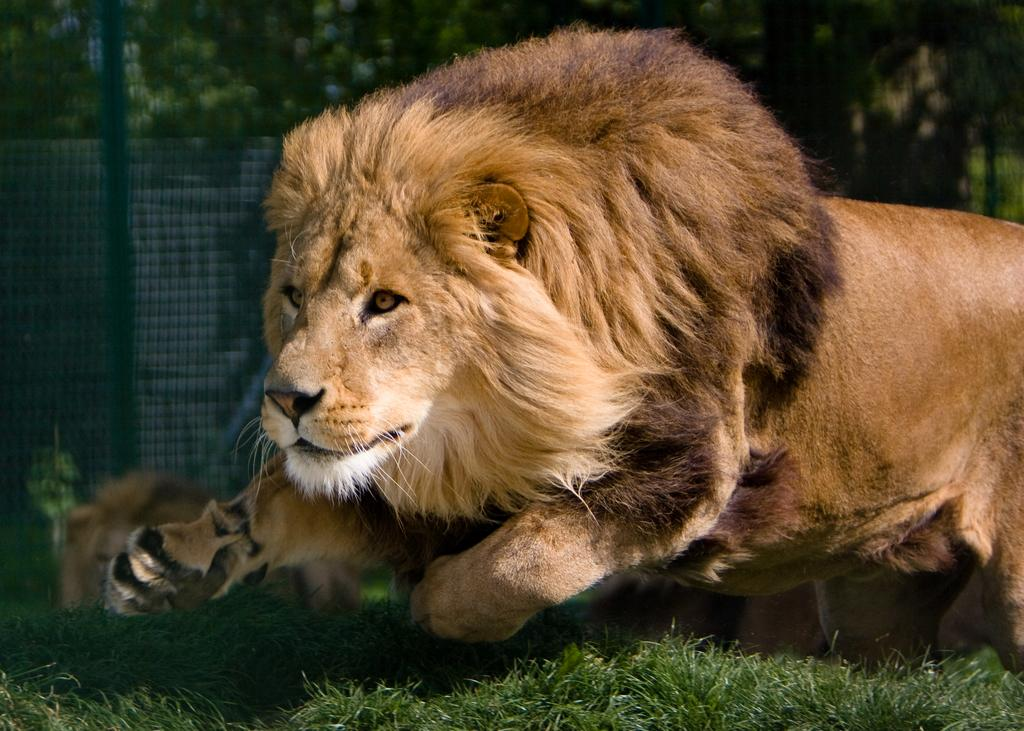What animals are present in the image? There are two lions in the image. What type of terrain is visible at the bottom of the image? There is grass at the bottom of the image. What can be seen in the background of the image? There is a net in the background of the image. What type of vegetation is visible at the top of the image? There are trees at the top of the image. Can you see the lions reading a book in the image? There is no book or reading activity depicted in the image; it features two lions in a natural setting. 